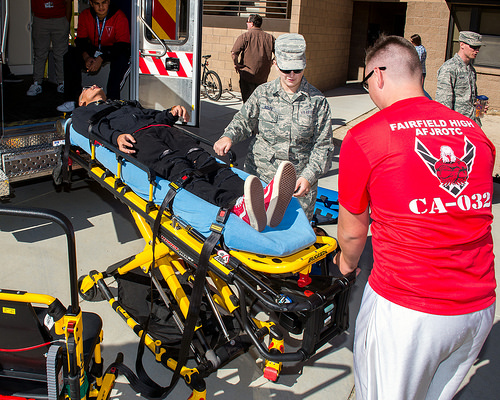<image>
Is the red shoes on the stretcher? Yes. Looking at the image, I can see the red shoes is positioned on top of the stretcher, with the stretcher providing support. Is the man on the bed? Yes. Looking at the image, I can see the man is positioned on top of the bed, with the bed providing support. 